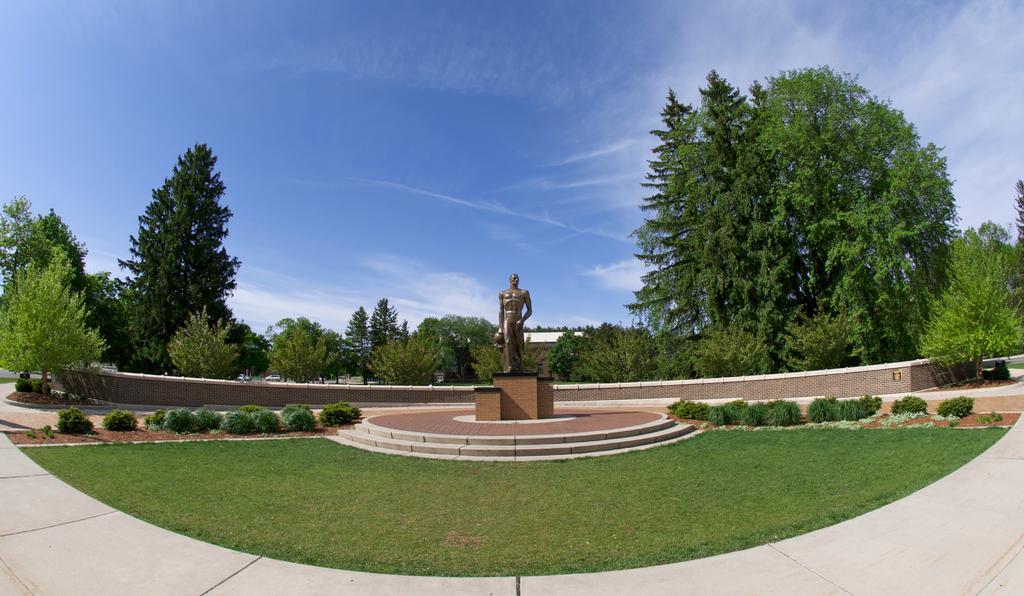Please provide a concise description of this image. In the center of the image we can see a statue. We can also see the staircase, some plants, grass, a pathway, a group of trees, a wall, some vehicles on the ground and the sky which looks cloudy. 